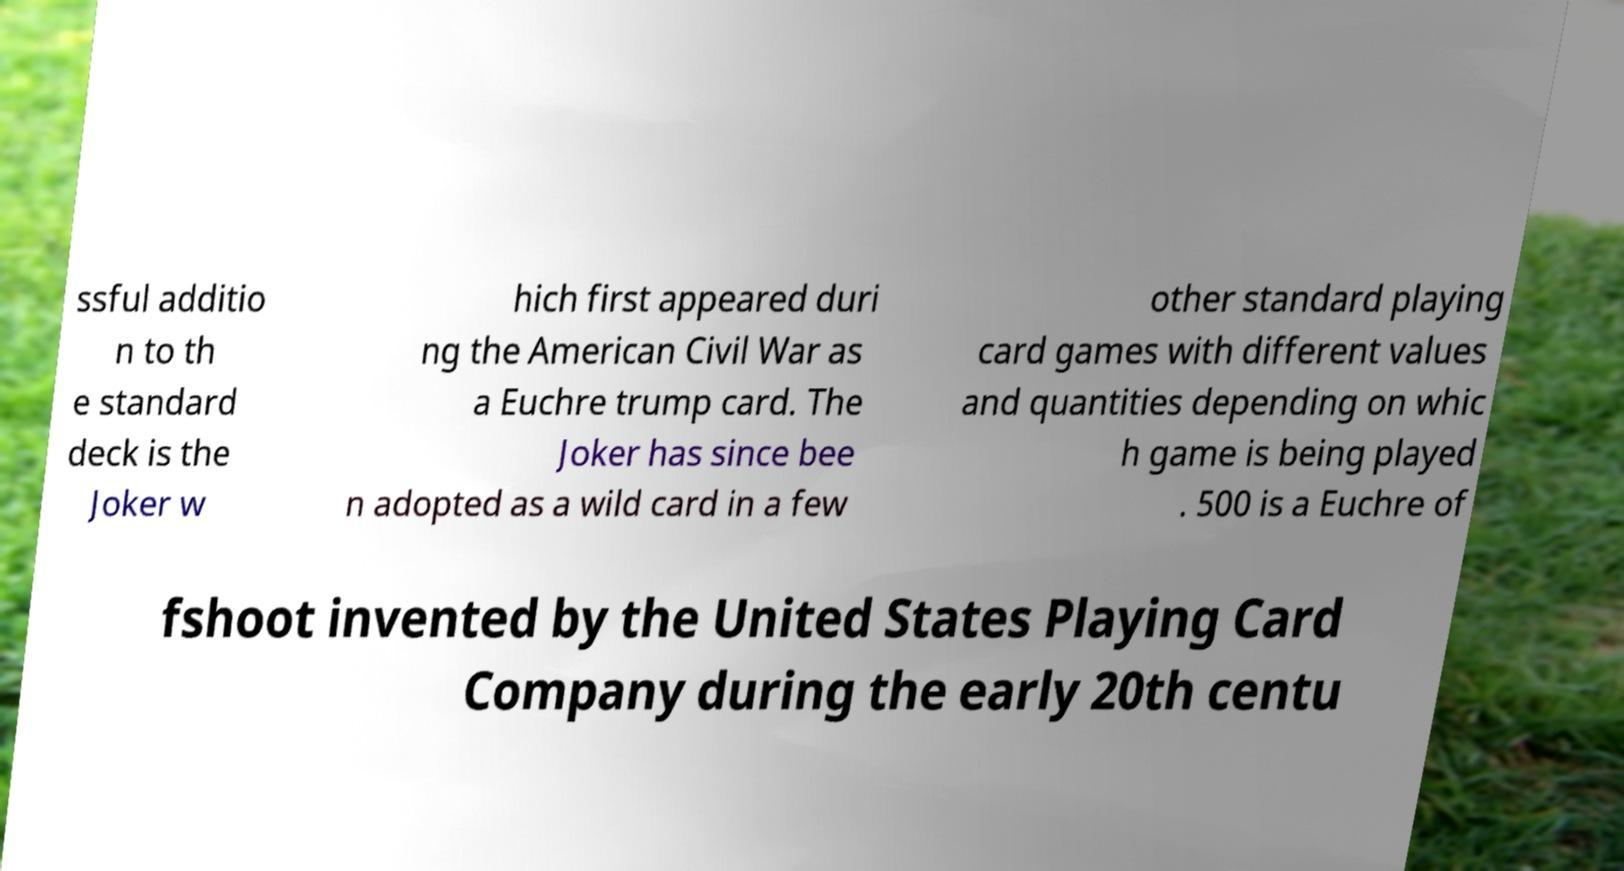Please identify and transcribe the text found in this image. ssful additio n to th e standard deck is the Joker w hich first appeared duri ng the American Civil War as a Euchre trump card. The Joker has since bee n adopted as a wild card in a few other standard playing card games with different values and quantities depending on whic h game is being played . 500 is a Euchre of fshoot invented by the United States Playing Card Company during the early 20th centu 